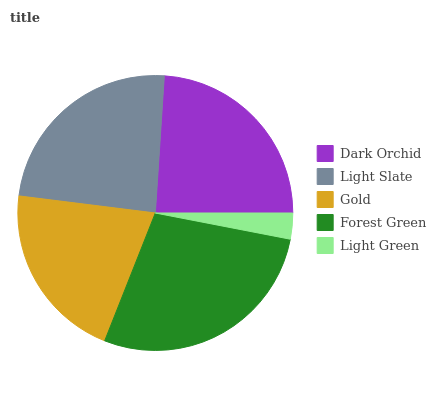Is Light Green the minimum?
Answer yes or no. Yes. Is Forest Green the maximum?
Answer yes or no. Yes. Is Light Slate the minimum?
Answer yes or no. No. Is Light Slate the maximum?
Answer yes or no. No. Is Light Slate greater than Dark Orchid?
Answer yes or no. Yes. Is Dark Orchid less than Light Slate?
Answer yes or no. Yes. Is Dark Orchid greater than Light Slate?
Answer yes or no. No. Is Light Slate less than Dark Orchid?
Answer yes or no. No. Is Dark Orchid the high median?
Answer yes or no. Yes. Is Dark Orchid the low median?
Answer yes or no. Yes. Is Gold the high median?
Answer yes or no. No. Is Gold the low median?
Answer yes or no. No. 